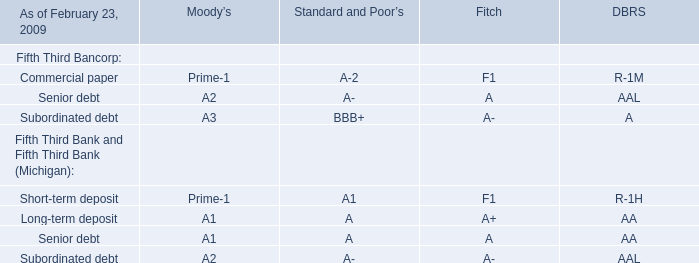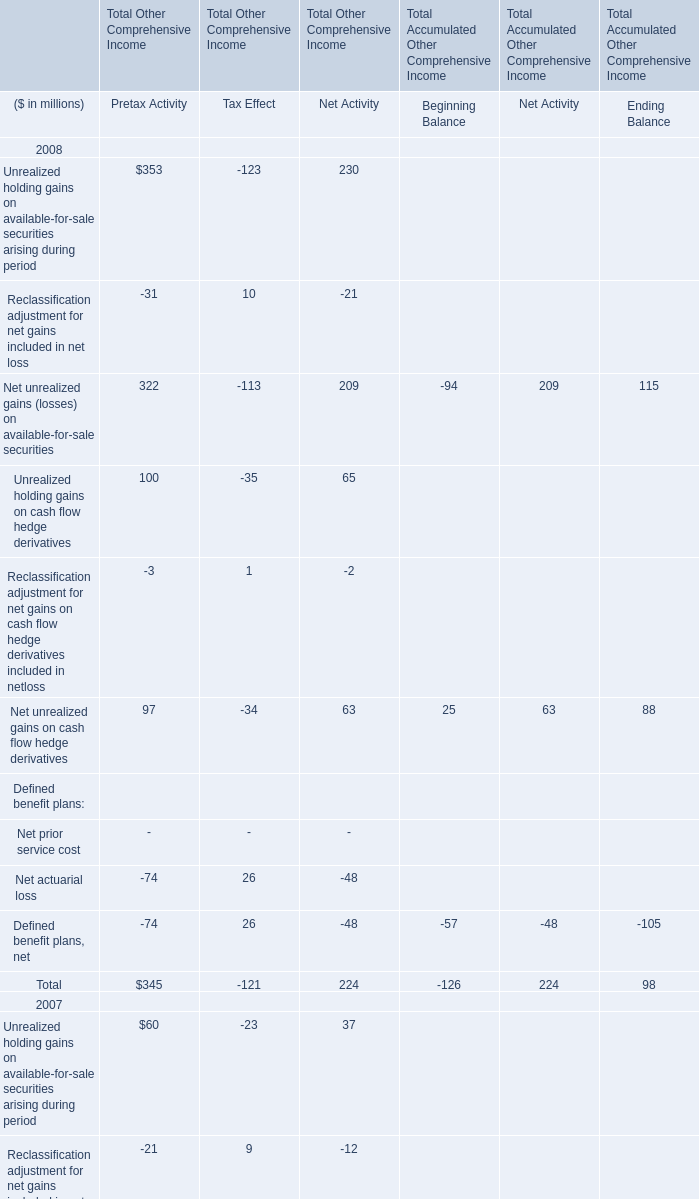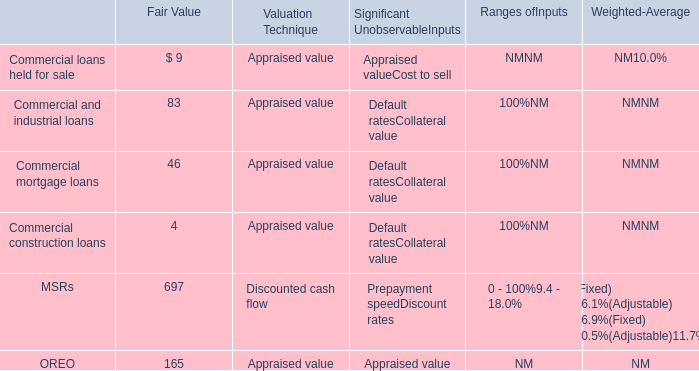What is the proportion of Reclassification adjustment for net gains included in net loss of Total Other Comprehensive Income to the total in2008? 
Computations: (322 / 345)
Answer: 0.93333. 